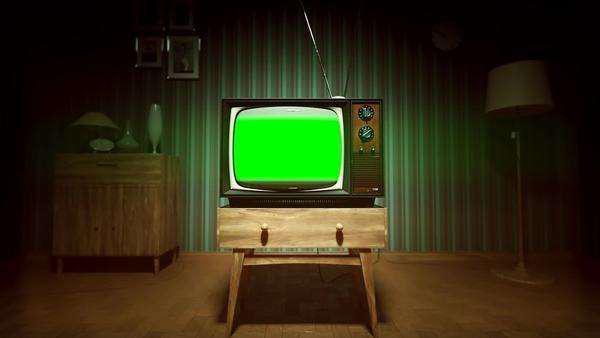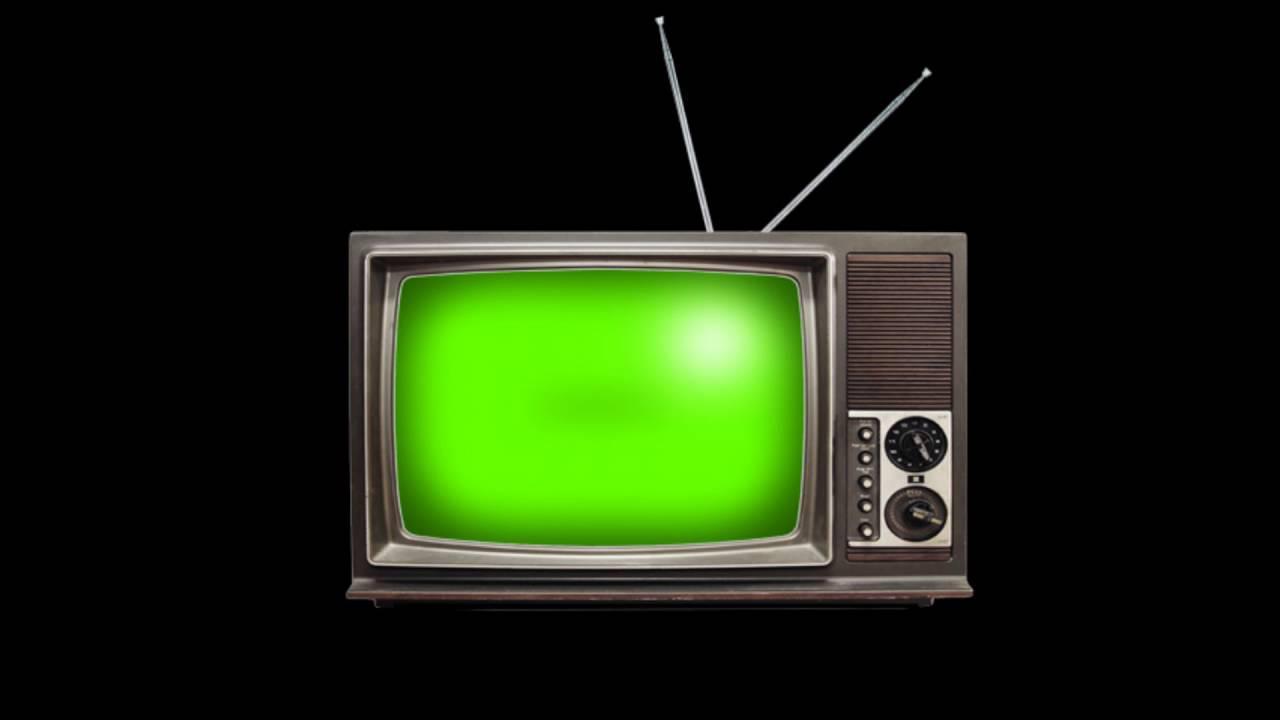The first image is the image on the left, the second image is the image on the right. Evaluate the accuracy of this statement regarding the images: "Each image shows vertical stacks containing at least eight TV sets, and no image includes any part of a human.". Is it true? Answer yes or no. No. The first image is the image on the left, the second image is the image on the right. Analyze the images presented: Is the assertion "There are less than five television sets  in at least one of the images." valid? Answer yes or no. Yes. 